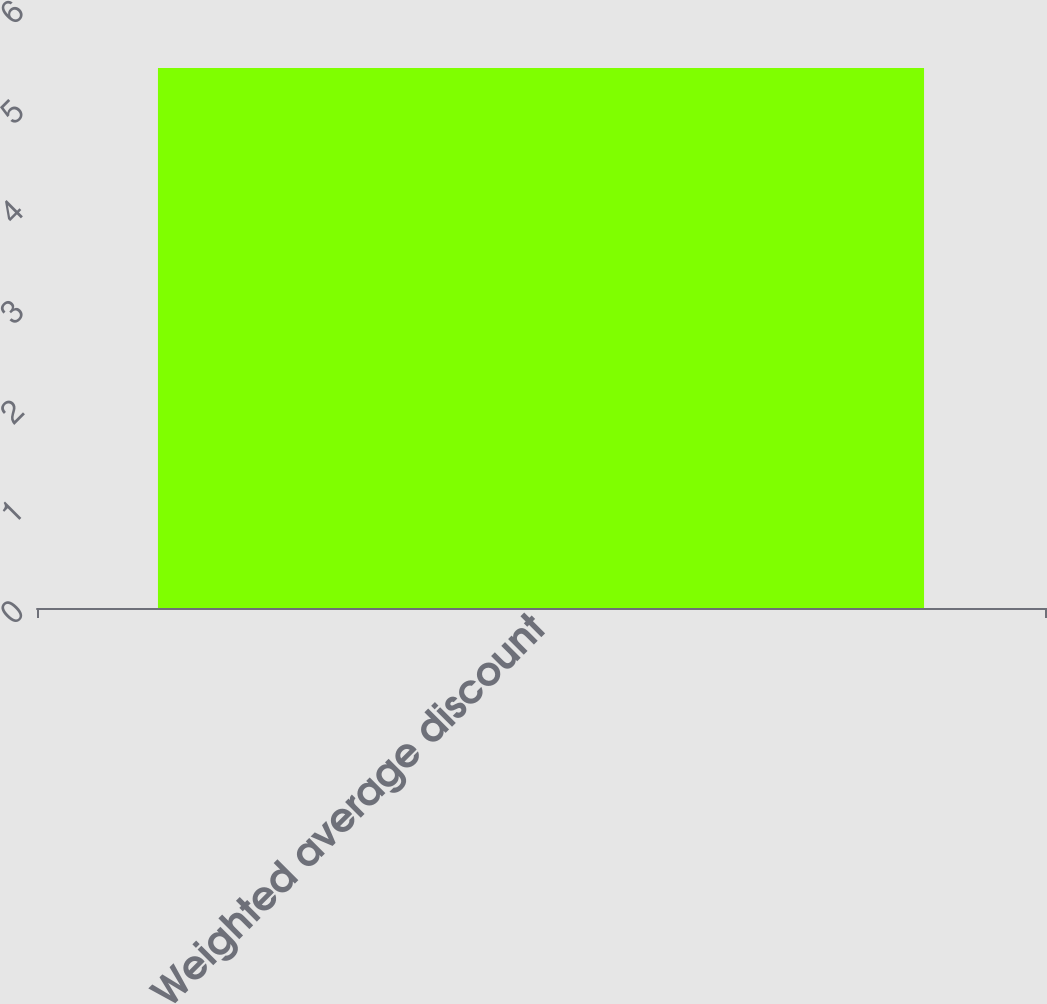Convert chart to OTSL. <chart><loc_0><loc_0><loc_500><loc_500><bar_chart><fcel>Weighted average discount<nl><fcel>5.4<nl></chart> 